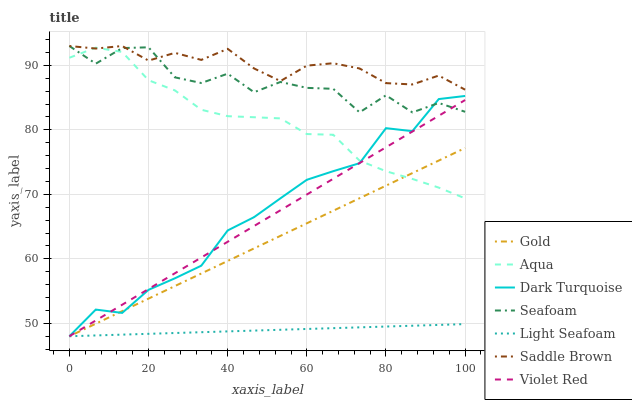Does Light Seafoam have the minimum area under the curve?
Answer yes or no. Yes. Does Saddle Brown have the maximum area under the curve?
Answer yes or no. Yes. Does Gold have the minimum area under the curve?
Answer yes or no. No. Does Gold have the maximum area under the curve?
Answer yes or no. No. Is Violet Red the smoothest?
Answer yes or no. Yes. Is Seafoam the roughest?
Answer yes or no. Yes. Is Gold the smoothest?
Answer yes or no. No. Is Gold the roughest?
Answer yes or no. No. Does Violet Red have the lowest value?
Answer yes or no. Yes. Does Aqua have the lowest value?
Answer yes or no. No. Does Saddle Brown have the highest value?
Answer yes or no. Yes. Does Gold have the highest value?
Answer yes or no. No. Is Violet Red less than Saddle Brown?
Answer yes or no. Yes. Is Saddle Brown greater than Light Seafoam?
Answer yes or no. Yes. Does Dark Turquoise intersect Aqua?
Answer yes or no. Yes. Is Dark Turquoise less than Aqua?
Answer yes or no. No. Is Dark Turquoise greater than Aqua?
Answer yes or no. No. Does Violet Red intersect Saddle Brown?
Answer yes or no. No. 